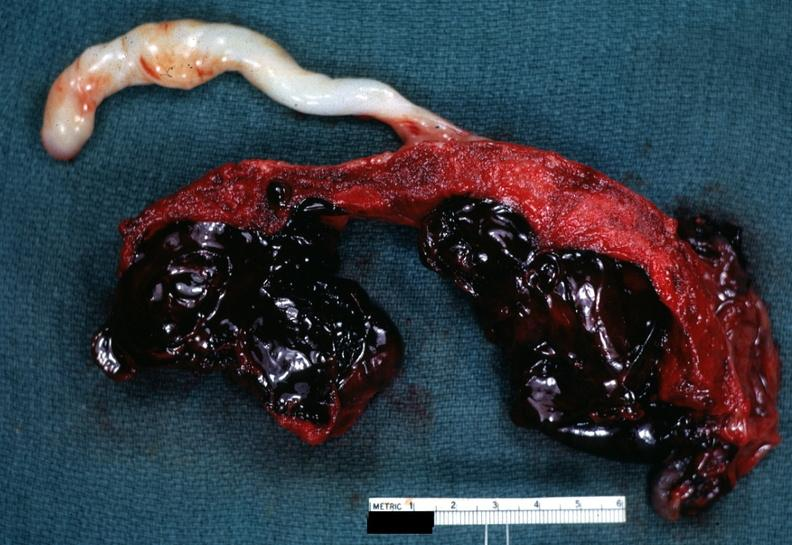s palmar crease normal present?
Answer the question using a single word or phrase. No 